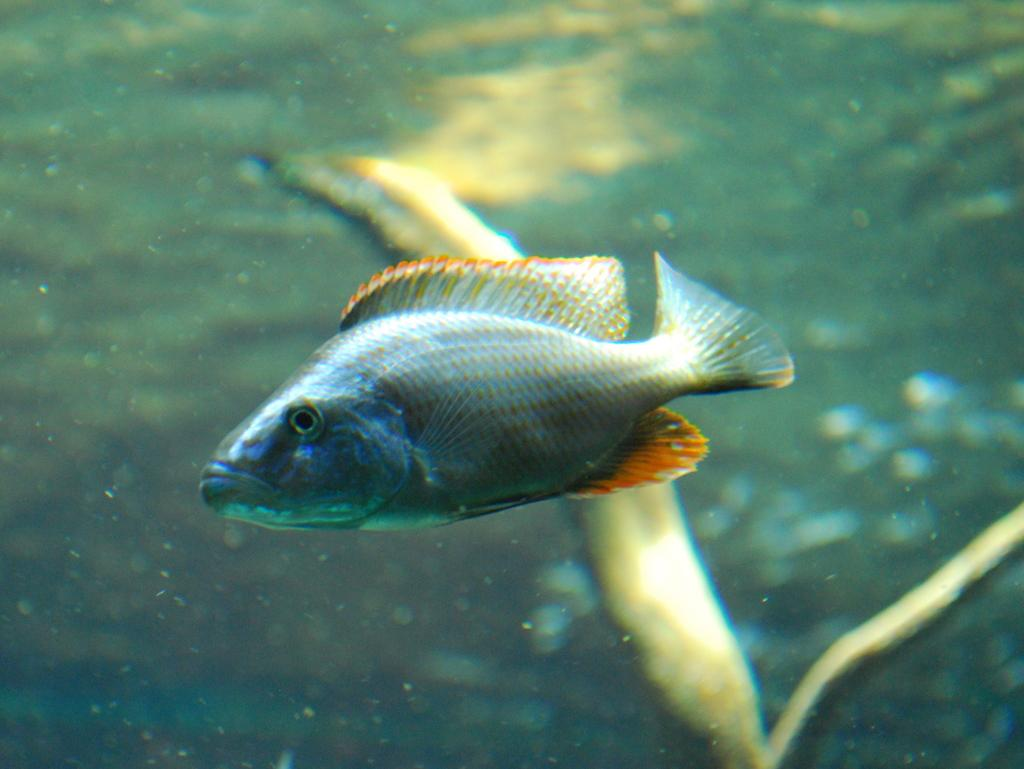What is the main subject of the image? The main subject of the image is a fish. Where is the fish located? The fish is in the water. Can you describe the background of the image? The background of the image is blurry. What type of request can be seen in the image? There is no request present in the image; it features a fish in the water with a blurry background. 